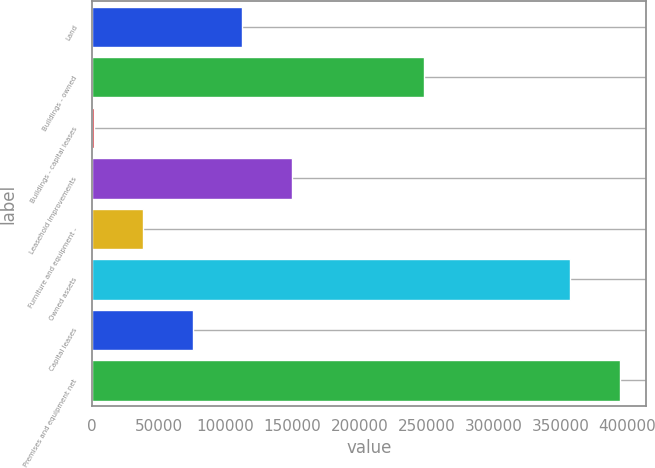Convert chart. <chart><loc_0><loc_0><loc_500><loc_500><bar_chart><fcel>Land<fcel>Buildings - owned<fcel>Buildings - capital leases<fcel>Leasehold improvements<fcel>Furniture and equipment -<fcel>Owned assets<fcel>Capital leases<fcel>Premises and equipment net<nl><fcel>112348<fcel>247834<fcel>1598<fcel>149265<fcel>38514.7<fcel>357478<fcel>75431.4<fcel>394395<nl></chart> 